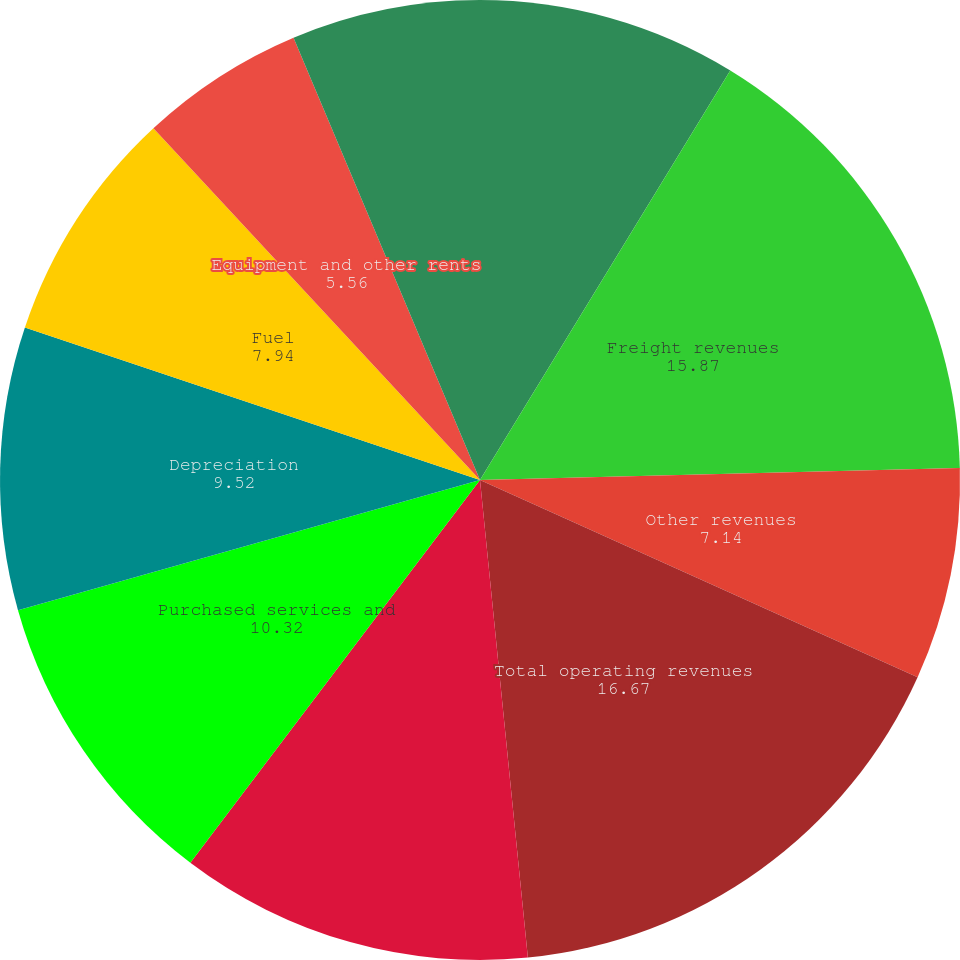Convert chart. <chart><loc_0><loc_0><loc_500><loc_500><pie_chart><fcel>Millions Except Per Share<fcel>Freight revenues<fcel>Other revenues<fcel>Total operating revenues<fcel>Compensation and benefits<fcel>Purchased services and<fcel>Depreciation<fcel>Fuel<fcel>Equipment and other rents<fcel>Other<nl><fcel>8.73%<fcel>15.87%<fcel>7.14%<fcel>16.67%<fcel>11.9%<fcel>10.32%<fcel>9.52%<fcel>7.94%<fcel>5.56%<fcel>6.35%<nl></chart> 